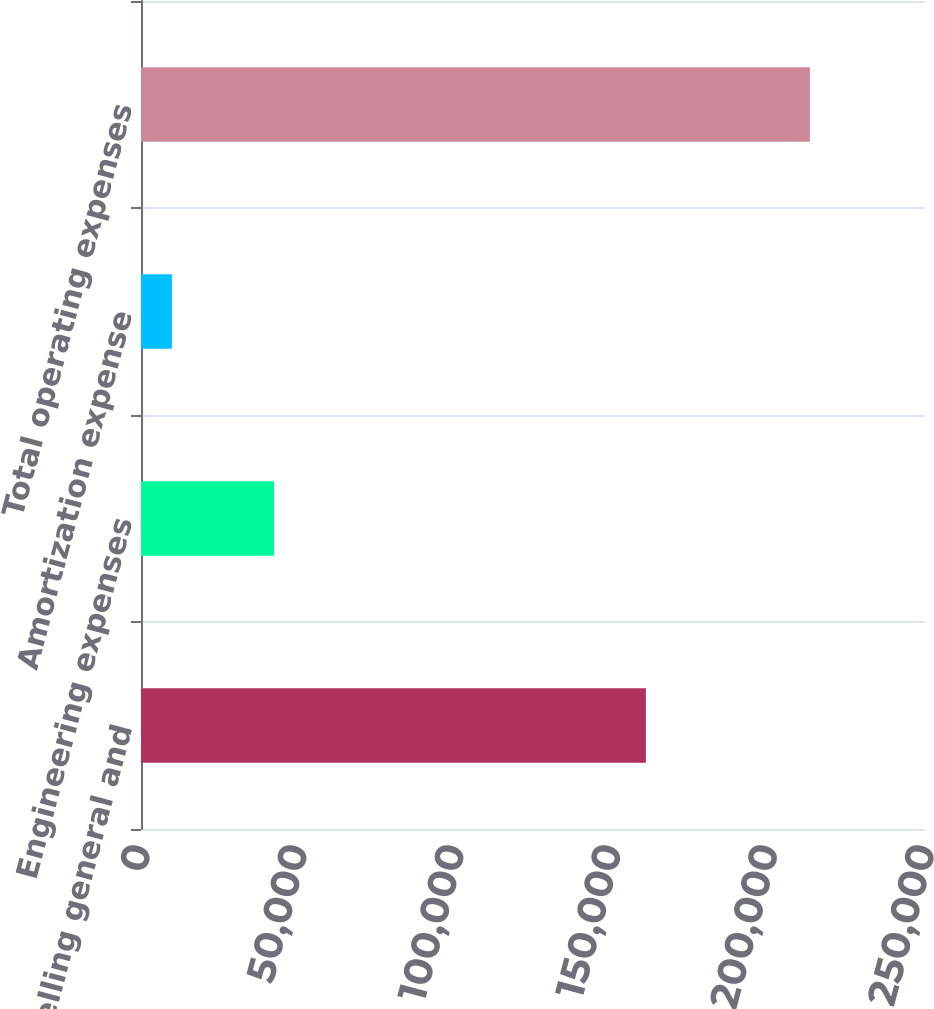Convert chart to OTSL. <chart><loc_0><loc_0><loc_500><loc_500><bar_chart><fcel>Selling general and<fcel>Engineering expenses<fcel>Amortization expense<fcel>Total operating expenses<nl><fcel>160998<fcel>42447<fcel>9849<fcel>213294<nl></chart> 